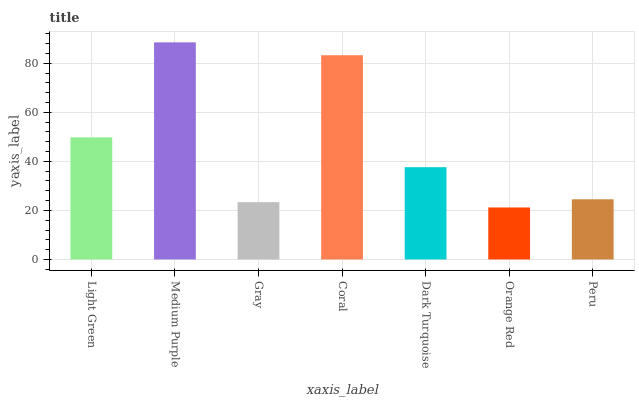Is Orange Red the minimum?
Answer yes or no. Yes. Is Medium Purple the maximum?
Answer yes or no. Yes. Is Gray the minimum?
Answer yes or no. No. Is Gray the maximum?
Answer yes or no. No. Is Medium Purple greater than Gray?
Answer yes or no. Yes. Is Gray less than Medium Purple?
Answer yes or no. Yes. Is Gray greater than Medium Purple?
Answer yes or no. No. Is Medium Purple less than Gray?
Answer yes or no. No. Is Dark Turquoise the high median?
Answer yes or no. Yes. Is Dark Turquoise the low median?
Answer yes or no. Yes. Is Gray the high median?
Answer yes or no. No. Is Orange Red the low median?
Answer yes or no. No. 